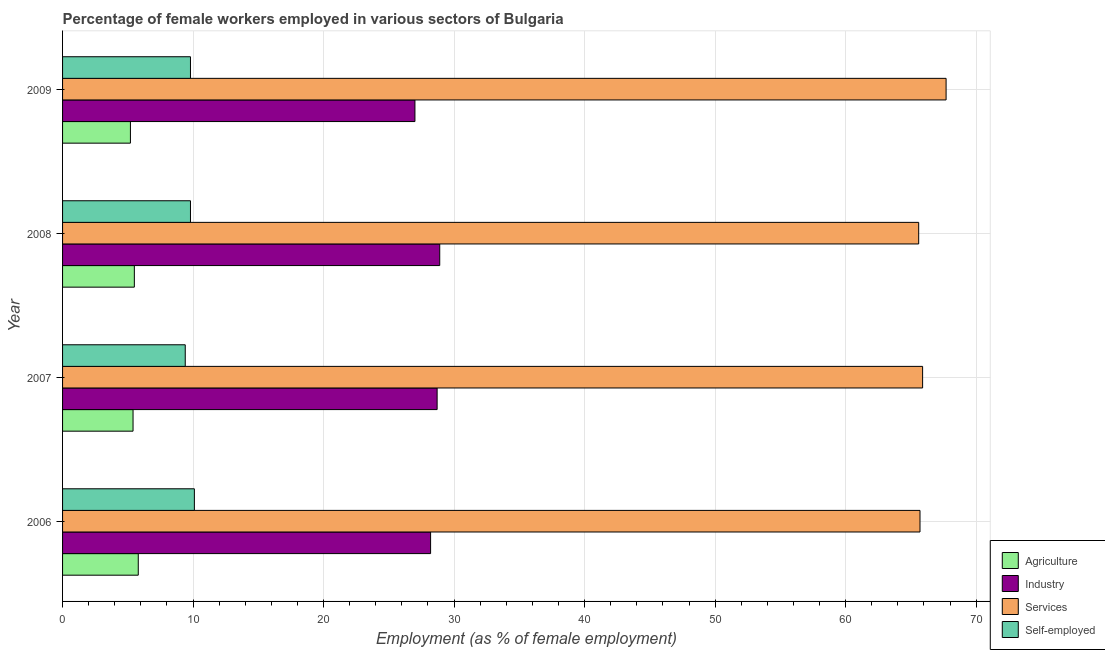How many groups of bars are there?
Provide a short and direct response. 4. How many bars are there on the 2nd tick from the bottom?
Your answer should be very brief. 4. What is the percentage of female workers in agriculture in 2008?
Provide a short and direct response. 5.5. Across all years, what is the maximum percentage of female workers in services?
Your answer should be compact. 67.7. Across all years, what is the minimum percentage of female workers in services?
Provide a succinct answer. 65.6. In which year was the percentage of female workers in agriculture minimum?
Your answer should be compact. 2009. What is the total percentage of female workers in services in the graph?
Keep it short and to the point. 264.9. What is the difference between the percentage of female workers in services in 2008 and the percentage of self employed female workers in 2007?
Ensure brevity in your answer.  56.2. What is the average percentage of female workers in agriculture per year?
Provide a short and direct response. 5.47. In the year 2007, what is the difference between the percentage of self employed female workers and percentage of female workers in services?
Your answer should be very brief. -56.5. In how many years, is the percentage of female workers in services greater than 64 %?
Your answer should be very brief. 4. What is the ratio of the percentage of self employed female workers in 2006 to that in 2009?
Make the answer very short. 1.03. What does the 4th bar from the top in 2007 represents?
Make the answer very short. Agriculture. What does the 3rd bar from the bottom in 2009 represents?
Provide a short and direct response. Services. Is it the case that in every year, the sum of the percentage of female workers in agriculture and percentage of female workers in industry is greater than the percentage of female workers in services?
Provide a short and direct response. No. Are all the bars in the graph horizontal?
Provide a short and direct response. Yes. Does the graph contain any zero values?
Keep it short and to the point. No. Where does the legend appear in the graph?
Your answer should be very brief. Bottom right. How are the legend labels stacked?
Offer a terse response. Vertical. What is the title of the graph?
Your answer should be very brief. Percentage of female workers employed in various sectors of Bulgaria. What is the label or title of the X-axis?
Make the answer very short. Employment (as % of female employment). What is the label or title of the Y-axis?
Provide a short and direct response. Year. What is the Employment (as % of female employment) of Agriculture in 2006?
Keep it short and to the point. 5.8. What is the Employment (as % of female employment) of Industry in 2006?
Ensure brevity in your answer.  28.2. What is the Employment (as % of female employment) in Services in 2006?
Provide a short and direct response. 65.7. What is the Employment (as % of female employment) in Self-employed in 2006?
Your response must be concise. 10.1. What is the Employment (as % of female employment) in Agriculture in 2007?
Provide a short and direct response. 5.4. What is the Employment (as % of female employment) of Industry in 2007?
Provide a succinct answer. 28.7. What is the Employment (as % of female employment) of Services in 2007?
Your answer should be compact. 65.9. What is the Employment (as % of female employment) of Self-employed in 2007?
Keep it short and to the point. 9.4. What is the Employment (as % of female employment) of Industry in 2008?
Your answer should be very brief. 28.9. What is the Employment (as % of female employment) of Services in 2008?
Ensure brevity in your answer.  65.6. What is the Employment (as % of female employment) in Self-employed in 2008?
Ensure brevity in your answer.  9.8. What is the Employment (as % of female employment) of Agriculture in 2009?
Ensure brevity in your answer.  5.2. What is the Employment (as % of female employment) in Services in 2009?
Give a very brief answer. 67.7. What is the Employment (as % of female employment) in Self-employed in 2009?
Provide a short and direct response. 9.8. Across all years, what is the maximum Employment (as % of female employment) of Agriculture?
Keep it short and to the point. 5.8. Across all years, what is the maximum Employment (as % of female employment) of Industry?
Provide a succinct answer. 28.9. Across all years, what is the maximum Employment (as % of female employment) of Services?
Make the answer very short. 67.7. Across all years, what is the maximum Employment (as % of female employment) in Self-employed?
Offer a terse response. 10.1. Across all years, what is the minimum Employment (as % of female employment) of Agriculture?
Offer a terse response. 5.2. Across all years, what is the minimum Employment (as % of female employment) of Industry?
Ensure brevity in your answer.  27. Across all years, what is the minimum Employment (as % of female employment) in Services?
Offer a very short reply. 65.6. Across all years, what is the minimum Employment (as % of female employment) in Self-employed?
Give a very brief answer. 9.4. What is the total Employment (as % of female employment) in Agriculture in the graph?
Ensure brevity in your answer.  21.9. What is the total Employment (as % of female employment) in Industry in the graph?
Give a very brief answer. 112.8. What is the total Employment (as % of female employment) in Services in the graph?
Ensure brevity in your answer.  264.9. What is the total Employment (as % of female employment) in Self-employed in the graph?
Offer a terse response. 39.1. What is the difference between the Employment (as % of female employment) of Services in 2006 and that in 2007?
Give a very brief answer. -0.2. What is the difference between the Employment (as % of female employment) of Self-employed in 2006 and that in 2007?
Offer a very short reply. 0.7. What is the difference between the Employment (as % of female employment) of Industry in 2006 and that in 2008?
Provide a succinct answer. -0.7. What is the difference between the Employment (as % of female employment) of Services in 2006 and that in 2008?
Your answer should be very brief. 0.1. What is the difference between the Employment (as % of female employment) in Self-employed in 2006 and that in 2008?
Provide a short and direct response. 0.3. What is the difference between the Employment (as % of female employment) in Industry in 2006 and that in 2009?
Give a very brief answer. 1.2. What is the difference between the Employment (as % of female employment) of Self-employed in 2006 and that in 2009?
Your answer should be very brief. 0.3. What is the difference between the Employment (as % of female employment) in Industry in 2007 and that in 2008?
Your response must be concise. -0.2. What is the difference between the Employment (as % of female employment) in Self-employed in 2007 and that in 2008?
Your response must be concise. -0.4. What is the difference between the Employment (as % of female employment) of Agriculture in 2007 and that in 2009?
Ensure brevity in your answer.  0.2. What is the difference between the Employment (as % of female employment) of Industry in 2007 and that in 2009?
Offer a very short reply. 1.7. What is the difference between the Employment (as % of female employment) of Agriculture in 2008 and that in 2009?
Provide a succinct answer. 0.3. What is the difference between the Employment (as % of female employment) in Industry in 2008 and that in 2009?
Provide a succinct answer. 1.9. What is the difference between the Employment (as % of female employment) in Services in 2008 and that in 2009?
Make the answer very short. -2.1. What is the difference between the Employment (as % of female employment) of Agriculture in 2006 and the Employment (as % of female employment) of Industry in 2007?
Offer a terse response. -22.9. What is the difference between the Employment (as % of female employment) in Agriculture in 2006 and the Employment (as % of female employment) in Services in 2007?
Ensure brevity in your answer.  -60.1. What is the difference between the Employment (as % of female employment) of Agriculture in 2006 and the Employment (as % of female employment) of Self-employed in 2007?
Make the answer very short. -3.6. What is the difference between the Employment (as % of female employment) of Industry in 2006 and the Employment (as % of female employment) of Services in 2007?
Your answer should be compact. -37.7. What is the difference between the Employment (as % of female employment) of Industry in 2006 and the Employment (as % of female employment) of Self-employed in 2007?
Keep it short and to the point. 18.8. What is the difference between the Employment (as % of female employment) of Services in 2006 and the Employment (as % of female employment) of Self-employed in 2007?
Ensure brevity in your answer.  56.3. What is the difference between the Employment (as % of female employment) in Agriculture in 2006 and the Employment (as % of female employment) in Industry in 2008?
Keep it short and to the point. -23.1. What is the difference between the Employment (as % of female employment) in Agriculture in 2006 and the Employment (as % of female employment) in Services in 2008?
Provide a succinct answer. -59.8. What is the difference between the Employment (as % of female employment) of Industry in 2006 and the Employment (as % of female employment) of Services in 2008?
Offer a very short reply. -37.4. What is the difference between the Employment (as % of female employment) in Industry in 2006 and the Employment (as % of female employment) in Self-employed in 2008?
Your answer should be compact. 18.4. What is the difference between the Employment (as % of female employment) in Services in 2006 and the Employment (as % of female employment) in Self-employed in 2008?
Your answer should be compact. 55.9. What is the difference between the Employment (as % of female employment) of Agriculture in 2006 and the Employment (as % of female employment) of Industry in 2009?
Your response must be concise. -21.2. What is the difference between the Employment (as % of female employment) of Agriculture in 2006 and the Employment (as % of female employment) of Services in 2009?
Provide a short and direct response. -61.9. What is the difference between the Employment (as % of female employment) in Industry in 2006 and the Employment (as % of female employment) in Services in 2009?
Provide a short and direct response. -39.5. What is the difference between the Employment (as % of female employment) of Industry in 2006 and the Employment (as % of female employment) of Self-employed in 2009?
Your answer should be compact. 18.4. What is the difference between the Employment (as % of female employment) of Services in 2006 and the Employment (as % of female employment) of Self-employed in 2009?
Make the answer very short. 55.9. What is the difference between the Employment (as % of female employment) in Agriculture in 2007 and the Employment (as % of female employment) in Industry in 2008?
Your answer should be very brief. -23.5. What is the difference between the Employment (as % of female employment) in Agriculture in 2007 and the Employment (as % of female employment) in Services in 2008?
Ensure brevity in your answer.  -60.2. What is the difference between the Employment (as % of female employment) of Agriculture in 2007 and the Employment (as % of female employment) of Self-employed in 2008?
Give a very brief answer. -4.4. What is the difference between the Employment (as % of female employment) of Industry in 2007 and the Employment (as % of female employment) of Services in 2008?
Keep it short and to the point. -36.9. What is the difference between the Employment (as % of female employment) of Services in 2007 and the Employment (as % of female employment) of Self-employed in 2008?
Ensure brevity in your answer.  56.1. What is the difference between the Employment (as % of female employment) of Agriculture in 2007 and the Employment (as % of female employment) of Industry in 2009?
Provide a short and direct response. -21.6. What is the difference between the Employment (as % of female employment) of Agriculture in 2007 and the Employment (as % of female employment) of Services in 2009?
Give a very brief answer. -62.3. What is the difference between the Employment (as % of female employment) in Industry in 2007 and the Employment (as % of female employment) in Services in 2009?
Ensure brevity in your answer.  -39. What is the difference between the Employment (as % of female employment) of Industry in 2007 and the Employment (as % of female employment) of Self-employed in 2009?
Your answer should be compact. 18.9. What is the difference between the Employment (as % of female employment) in Services in 2007 and the Employment (as % of female employment) in Self-employed in 2009?
Your answer should be compact. 56.1. What is the difference between the Employment (as % of female employment) of Agriculture in 2008 and the Employment (as % of female employment) of Industry in 2009?
Provide a short and direct response. -21.5. What is the difference between the Employment (as % of female employment) of Agriculture in 2008 and the Employment (as % of female employment) of Services in 2009?
Give a very brief answer. -62.2. What is the difference between the Employment (as % of female employment) in Industry in 2008 and the Employment (as % of female employment) in Services in 2009?
Offer a very short reply. -38.8. What is the difference between the Employment (as % of female employment) in Services in 2008 and the Employment (as % of female employment) in Self-employed in 2009?
Provide a succinct answer. 55.8. What is the average Employment (as % of female employment) of Agriculture per year?
Provide a succinct answer. 5.47. What is the average Employment (as % of female employment) of Industry per year?
Keep it short and to the point. 28.2. What is the average Employment (as % of female employment) in Services per year?
Your answer should be compact. 66.22. What is the average Employment (as % of female employment) of Self-employed per year?
Give a very brief answer. 9.78. In the year 2006, what is the difference between the Employment (as % of female employment) in Agriculture and Employment (as % of female employment) in Industry?
Give a very brief answer. -22.4. In the year 2006, what is the difference between the Employment (as % of female employment) of Agriculture and Employment (as % of female employment) of Services?
Keep it short and to the point. -59.9. In the year 2006, what is the difference between the Employment (as % of female employment) in Industry and Employment (as % of female employment) in Services?
Provide a short and direct response. -37.5. In the year 2006, what is the difference between the Employment (as % of female employment) of Services and Employment (as % of female employment) of Self-employed?
Ensure brevity in your answer.  55.6. In the year 2007, what is the difference between the Employment (as % of female employment) of Agriculture and Employment (as % of female employment) of Industry?
Make the answer very short. -23.3. In the year 2007, what is the difference between the Employment (as % of female employment) of Agriculture and Employment (as % of female employment) of Services?
Offer a terse response. -60.5. In the year 2007, what is the difference between the Employment (as % of female employment) in Agriculture and Employment (as % of female employment) in Self-employed?
Provide a short and direct response. -4. In the year 2007, what is the difference between the Employment (as % of female employment) of Industry and Employment (as % of female employment) of Services?
Provide a succinct answer. -37.2. In the year 2007, what is the difference between the Employment (as % of female employment) of Industry and Employment (as % of female employment) of Self-employed?
Your answer should be compact. 19.3. In the year 2007, what is the difference between the Employment (as % of female employment) in Services and Employment (as % of female employment) in Self-employed?
Your response must be concise. 56.5. In the year 2008, what is the difference between the Employment (as % of female employment) in Agriculture and Employment (as % of female employment) in Industry?
Ensure brevity in your answer.  -23.4. In the year 2008, what is the difference between the Employment (as % of female employment) in Agriculture and Employment (as % of female employment) in Services?
Offer a terse response. -60.1. In the year 2008, what is the difference between the Employment (as % of female employment) of Industry and Employment (as % of female employment) of Services?
Make the answer very short. -36.7. In the year 2008, what is the difference between the Employment (as % of female employment) of Industry and Employment (as % of female employment) of Self-employed?
Offer a very short reply. 19.1. In the year 2008, what is the difference between the Employment (as % of female employment) of Services and Employment (as % of female employment) of Self-employed?
Your answer should be very brief. 55.8. In the year 2009, what is the difference between the Employment (as % of female employment) in Agriculture and Employment (as % of female employment) in Industry?
Ensure brevity in your answer.  -21.8. In the year 2009, what is the difference between the Employment (as % of female employment) of Agriculture and Employment (as % of female employment) of Services?
Ensure brevity in your answer.  -62.5. In the year 2009, what is the difference between the Employment (as % of female employment) of Agriculture and Employment (as % of female employment) of Self-employed?
Your response must be concise. -4.6. In the year 2009, what is the difference between the Employment (as % of female employment) of Industry and Employment (as % of female employment) of Services?
Offer a very short reply. -40.7. In the year 2009, what is the difference between the Employment (as % of female employment) in Services and Employment (as % of female employment) in Self-employed?
Offer a terse response. 57.9. What is the ratio of the Employment (as % of female employment) in Agriculture in 2006 to that in 2007?
Keep it short and to the point. 1.07. What is the ratio of the Employment (as % of female employment) in Industry in 2006 to that in 2007?
Provide a succinct answer. 0.98. What is the ratio of the Employment (as % of female employment) in Services in 2006 to that in 2007?
Your response must be concise. 1. What is the ratio of the Employment (as % of female employment) of Self-employed in 2006 to that in 2007?
Your answer should be compact. 1.07. What is the ratio of the Employment (as % of female employment) of Agriculture in 2006 to that in 2008?
Your answer should be very brief. 1.05. What is the ratio of the Employment (as % of female employment) of Industry in 2006 to that in 2008?
Offer a very short reply. 0.98. What is the ratio of the Employment (as % of female employment) of Self-employed in 2006 to that in 2008?
Offer a very short reply. 1.03. What is the ratio of the Employment (as % of female employment) in Agriculture in 2006 to that in 2009?
Provide a short and direct response. 1.12. What is the ratio of the Employment (as % of female employment) of Industry in 2006 to that in 2009?
Provide a short and direct response. 1.04. What is the ratio of the Employment (as % of female employment) of Services in 2006 to that in 2009?
Provide a short and direct response. 0.97. What is the ratio of the Employment (as % of female employment) of Self-employed in 2006 to that in 2009?
Give a very brief answer. 1.03. What is the ratio of the Employment (as % of female employment) of Agriculture in 2007 to that in 2008?
Offer a very short reply. 0.98. What is the ratio of the Employment (as % of female employment) in Services in 2007 to that in 2008?
Your answer should be compact. 1. What is the ratio of the Employment (as % of female employment) in Self-employed in 2007 to that in 2008?
Provide a succinct answer. 0.96. What is the ratio of the Employment (as % of female employment) in Agriculture in 2007 to that in 2009?
Offer a terse response. 1.04. What is the ratio of the Employment (as % of female employment) in Industry in 2007 to that in 2009?
Offer a terse response. 1.06. What is the ratio of the Employment (as % of female employment) in Services in 2007 to that in 2009?
Your response must be concise. 0.97. What is the ratio of the Employment (as % of female employment) of Self-employed in 2007 to that in 2009?
Your answer should be compact. 0.96. What is the ratio of the Employment (as % of female employment) in Agriculture in 2008 to that in 2009?
Provide a short and direct response. 1.06. What is the ratio of the Employment (as % of female employment) of Industry in 2008 to that in 2009?
Make the answer very short. 1.07. What is the ratio of the Employment (as % of female employment) in Services in 2008 to that in 2009?
Offer a very short reply. 0.97. What is the ratio of the Employment (as % of female employment) of Self-employed in 2008 to that in 2009?
Give a very brief answer. 1. What is the difference between the highest and the second highest Employment (as % of female employment) of Industry?
Ensure brevity in your answer.  0.2. What is the difference between the highest and the second highest Employment (as % of female employment) of Services?
Ensure brevity in your answer.  1.8. What is the difference between the highest and the second highest Employment (as % of female employment) in Self-employed?
Your answer should be compact. 0.3. What is the difference between the highest and the lowest Employment (as % of female employment) of Industry?
Keep it short and to the point. 1.9. 